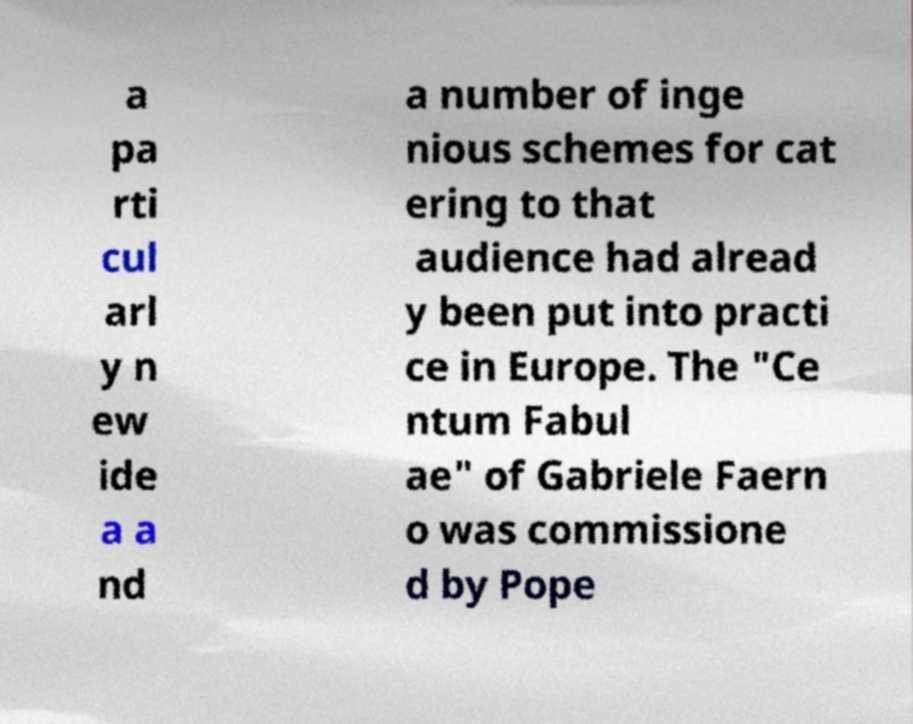For documentation purposes, I need the text within this image transcribed. Could you provide that? a pa rti cul arl y n ew ide a a nd a number of inge nious schemes for cat ering to that audience had alread y been put into practi ce in Europe. The "Ce ntum Fabul ae" of Gabriele Faern o was commissione d by Pope 